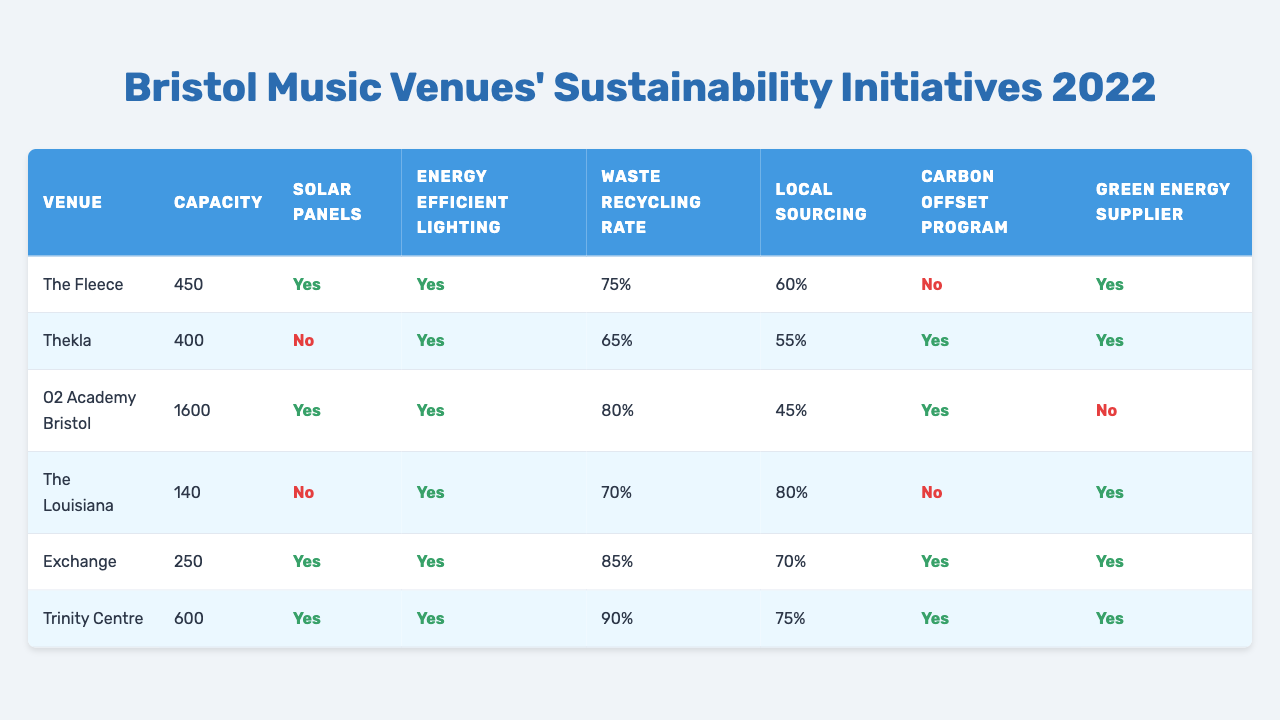What is the capacity of The Fleece? The capacity of The Fleece is listed in the table as 450.
Answer: 450 How many venues have solar panels installed? I need to check the “Solar Panels” column in the table. The Fleece, O2 Academy Bristol, Exchange, and Trinity Centre all have solar panels installed. That totals 4 venues.
Answer: 4 What is the waste recycling rate of Thekla? The waste recycling rate for Thekla is found in the table under the "Waste Recycling Rate" column, which states it is 65%.
Answer: 65 Which venue has the highest waste recycling rate? I will look at the "Waste Recycling Rate" column: The highest rate is 90%, visible next to Trinity Centre in the table.
Answer: Trinity Centre Is the O2 Academy Bristol using a green energy supplier? The information for O2 Academy Bristol in the "Green Energy Supplier" column shows it is marked as 'No.'
Answer: No What percentage of local sourcing does The Louisiana have? The Louisiana's local sourcing percentage is provided in the respective column in the table, which shows it to be 80%.
Answer: 80 Which venue is using energy-efficient lighting and has a carbon offset program? I’ll check the "Energy Efficient Lighting" and "Carbon Offset Program" columns in the table. Three venues meet these criteria: Exchange, Trinity Centre, and Thekla.
Answer: 3 Does The Fleece have a carbon offset program? Looking at the "Carbon Offset Program" column for The Fleece, it states 'No.'
Answer: No What is the average capacity of all the venues listed? I will sum the capacities: 450 + 400 + 1600 + 140 + 250 + 600 = 3440. There are 6 venues, so I divide: 3440/6 = 573.33. The average capacity is approximately 573.33.
Answer: 573.33 Which venue has both energy-efficient lighting and a waste recycling rate of at least 80%? From the table, I check venues with energy-efficient lighting and find that Exchange (85%) and Trinity Centre (90%) meet the minimum requirement.
Answer: 2 